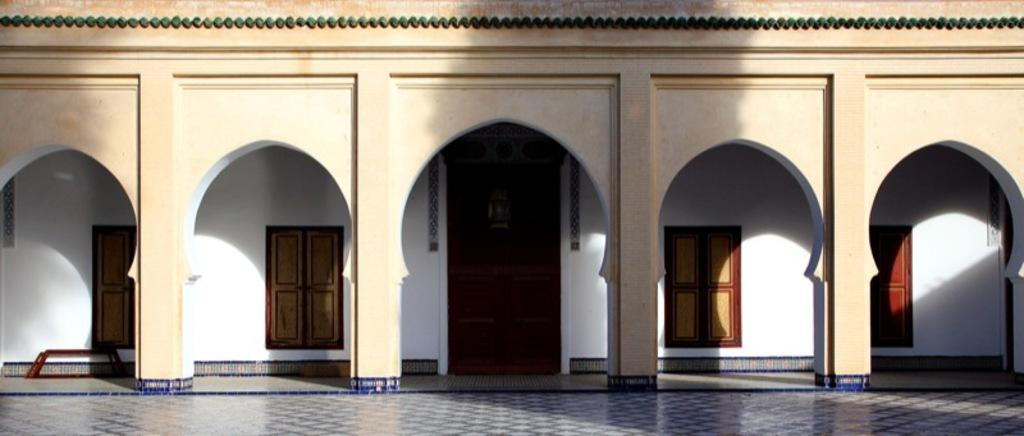What is the main subject of the image? The main subject of the image is a building. Can you describe the building in the image? The building has a door and windows. What is visible at the bottom of the image? There is a floor visible at the bottom of the image. What type of title is written on the door of the building in the image? There is no title visible on the door of the building in the image. Can you see any knees in the image? There are no knees visible in the image; it features a building with a door and windows. 